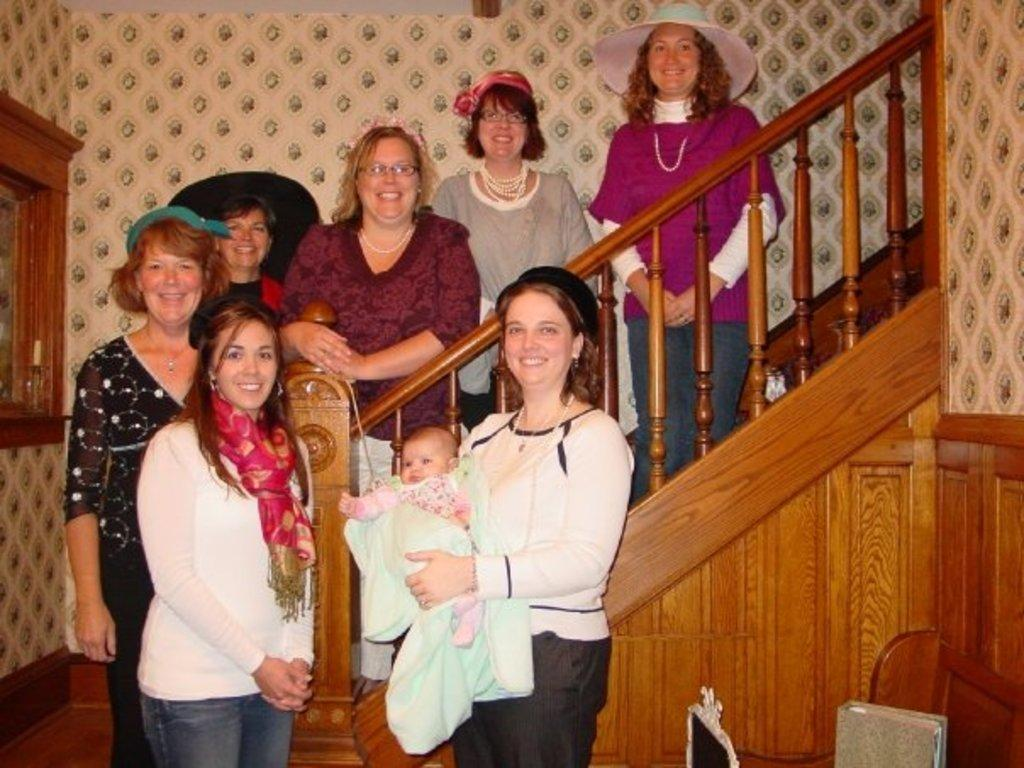How many people are in the image? There is a group of people in the image. What is the facial expression of the people in the image? The people are smiling. What is the woman in the image doing? A woman is carrying a baby. What architectural feature can be seen in the background of the image? There is a staircase in the background of the image. What is the color of the wall in the background of the image? The color of the wall in the background of the image is not mentioned in the facts. What objects can be seen in the background of the image? There are objects visible in the background of the image. What type of wood is the window made of in the image? There is no window mentioned in the image, so it is not possible to determine the type of wood it might be made of. 